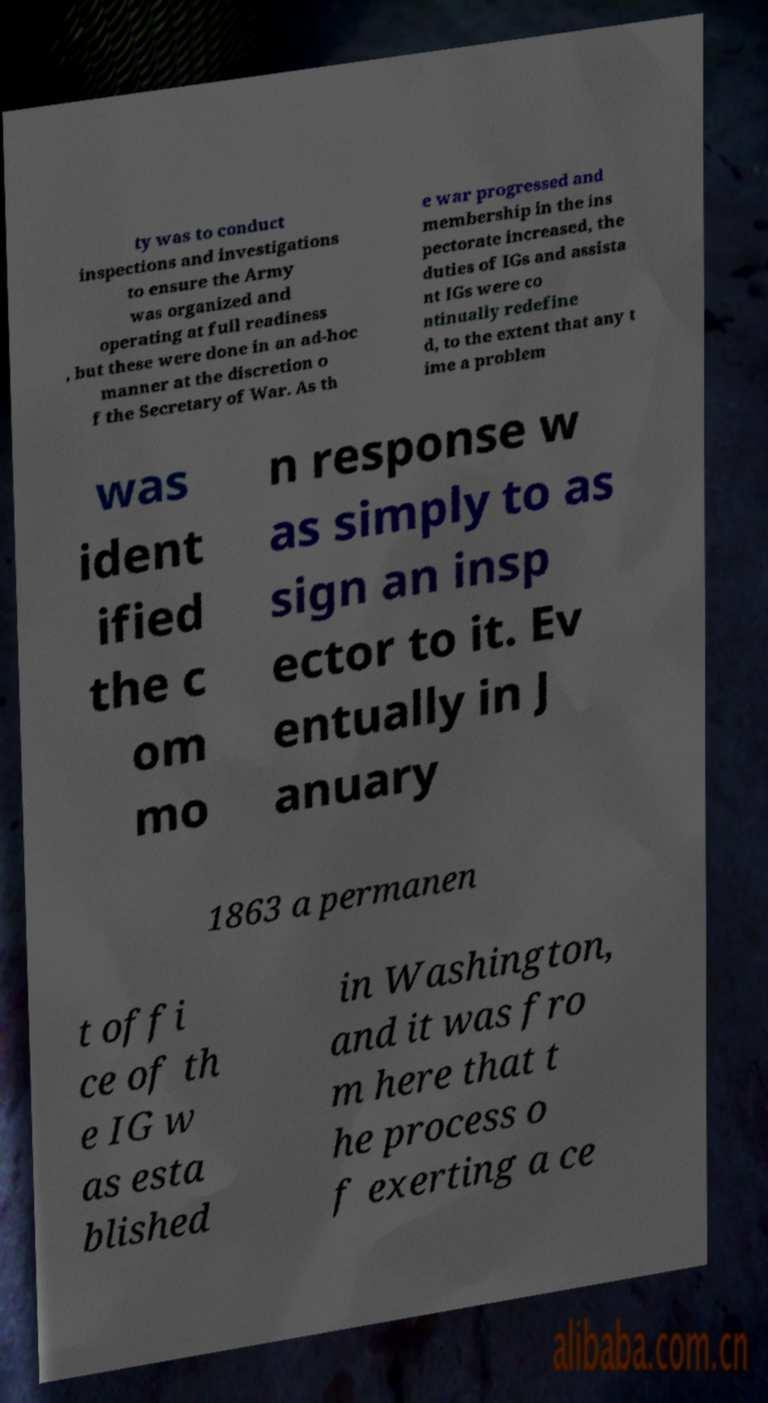I need the written content from this picture converted into text. Can you do that? ty was to conduct inspections and investigations to ensure the Army was organized and operating at full readiness , but these were done in an ad-hoc manner at the discretion o f the Secretary of War. As th e war progressed and membership in the ins pectorate increased, the duties of IGs and assista nt IGs were co ntinually redefine d, to the extent that any t ime a problem was ident ified the c om mo n response w as simply to as sign an insp ector to it. Ev entually in J anuary 1863 a permanen t offi ce of th e IG w as esta blished in Washington, and it was fro m here that t he process o f exerting a ce 